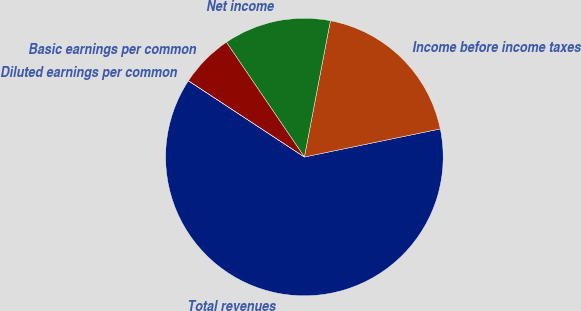Convert chart to OTSL. <chart><loc_0><loc_0><loc_500><loc_500><pie_chart><fcel>Total revenues<fcel>Income before income taxes<fcel>Net income<fcel>Basic earnings per common<fcel>Diluted earnings per common<nl><fcel>62.5%<fcel>18.75%<fcel>12.5%<fcel>6.25%<fcel>0.0%<nl></chart> 